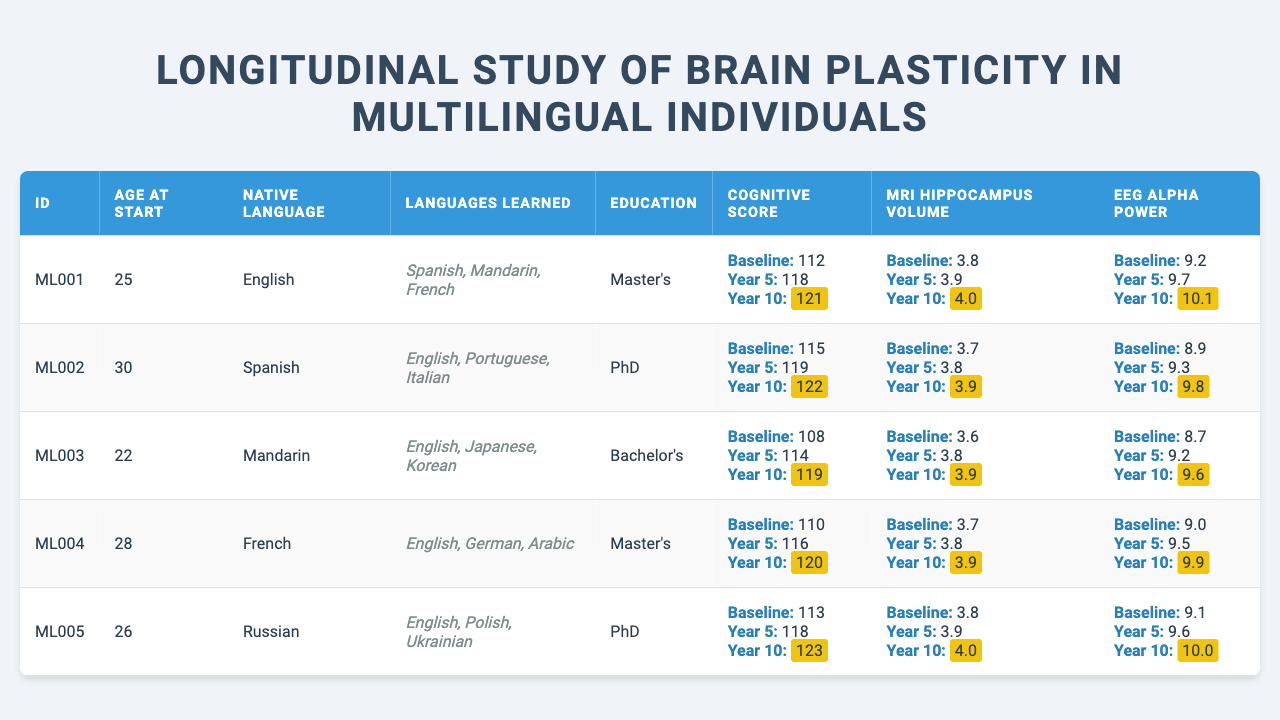What is the baseline cognitive score of participant ML005? The baseline cognitive score for ML005 is found directly in the table under "Cognitive Score" for the baseline category, which is 113.
Answer: 113 What languages has participant ML002 learned? By looking at the "Languages Learned" column for participant ML002, the languages listed are English, Portuguese, and Italian.
Answer: English, Portuguese, Italian What was the increase in cognitive score for participant ML001 from year 5 to year 10? For ML001, the cognitive score at year 5 was 118 and at year 10 it was 121. The increase is calculated as 121 - 118 = 3.
Answer: 3 Which participant had the highest baseline MRI hippocampus volume? To find the participant with the highest baseline MRI hippocampus volume, we look under "MRI Hippocampus Volume" in the baseline category. ML001, ML005, and ML004 have a baseline volume of 3.8, while others have lower values. Therefore, ML001, ML005, and ML004 share the highest value of 3.8.
Answer: ML001, ML005, ML004 Is participant ML003 younger than 25 years at the start of the study? The age of participant ML003 at the start is listed as 22, which is indeed younger than 25.
Answer: Yes What is the average year 10 EEG alpha power across all participants? The Year 10 EEG alpha power values for all participants are 10.1, 9.8, 9.6, 9.9, and 10.0. The total is 10.1 + 9.8 + 9.6 + 9.9 + 10.0 = 49.4, and the average is calculated as 49.4 / 5 = 9.88.
Answer: 9.88 Who has the highest education level and what is it? The education levels are listed as Master's and PhD. Participant ML002 and ML005 both have a PhD, which is higher than Master's.
Answer: PhD What is the difference between the baseline and year 10 MRI hippocampus volume for participant ML004? For ML004, the baseline MRI hippocampus volume is 3.7 and at year 10, it's 3.9. The difference is 3.9 - 3.7 = 0.2.
Answer: 0.2 Do all participants show an increase in EEG alpha power from baseline to year 10? By comparing the EEG alpha power values from baseline to year 10, we see all participants have higher values at year 10 compared to baseline, indicating an increase is observed across the board.
Answer: Yes What is the total change in cognitive scores for all participants from baseline to year 10? The changes from baseline to year 10 for each participant are as follows: 121-112 = 9, 122-115 = 7, 119-108 = 11, 120-110 = 10, and 123-113 = 10. The total change is 9 + 7 + 11 + 10 + 10 = 47.
Answer: 47 